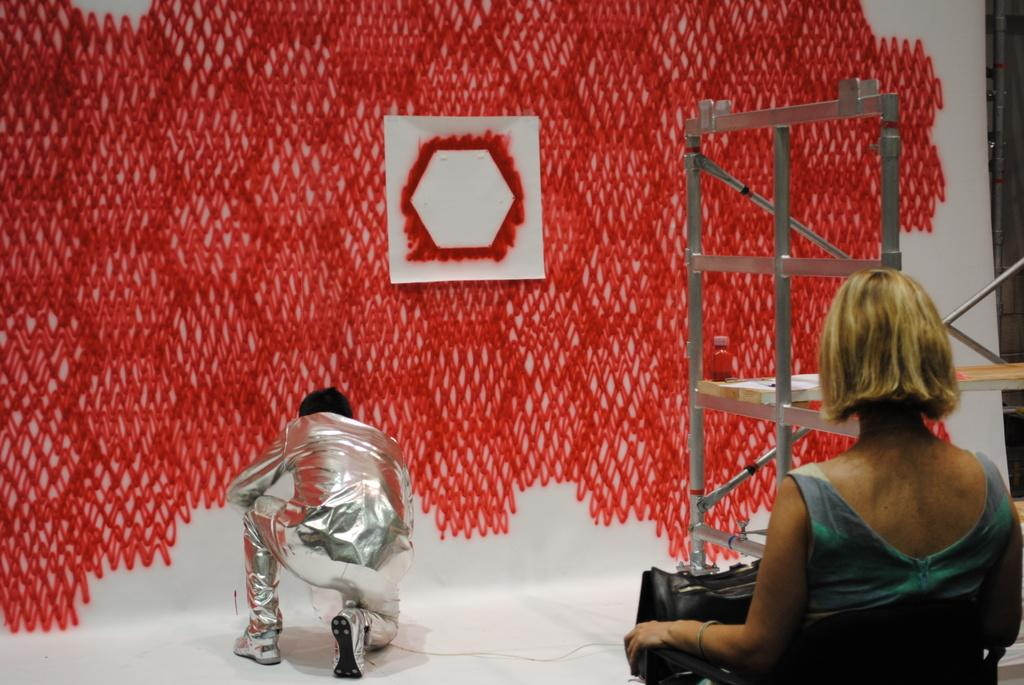How many people are present in the image? There are two people in the image. What can be seen in the image besides the people? There is a rack, a bottle, and a frame on a board in the background of the image. Can you describe the rack in the image? The facts do not provide a description of the rack, so we cannot describe it. What type of meal is being prepared by the people in the image? The facts do not mention any meal preparation or cooking activity in the image, so we cannot determine what type of meal is being prepared. 